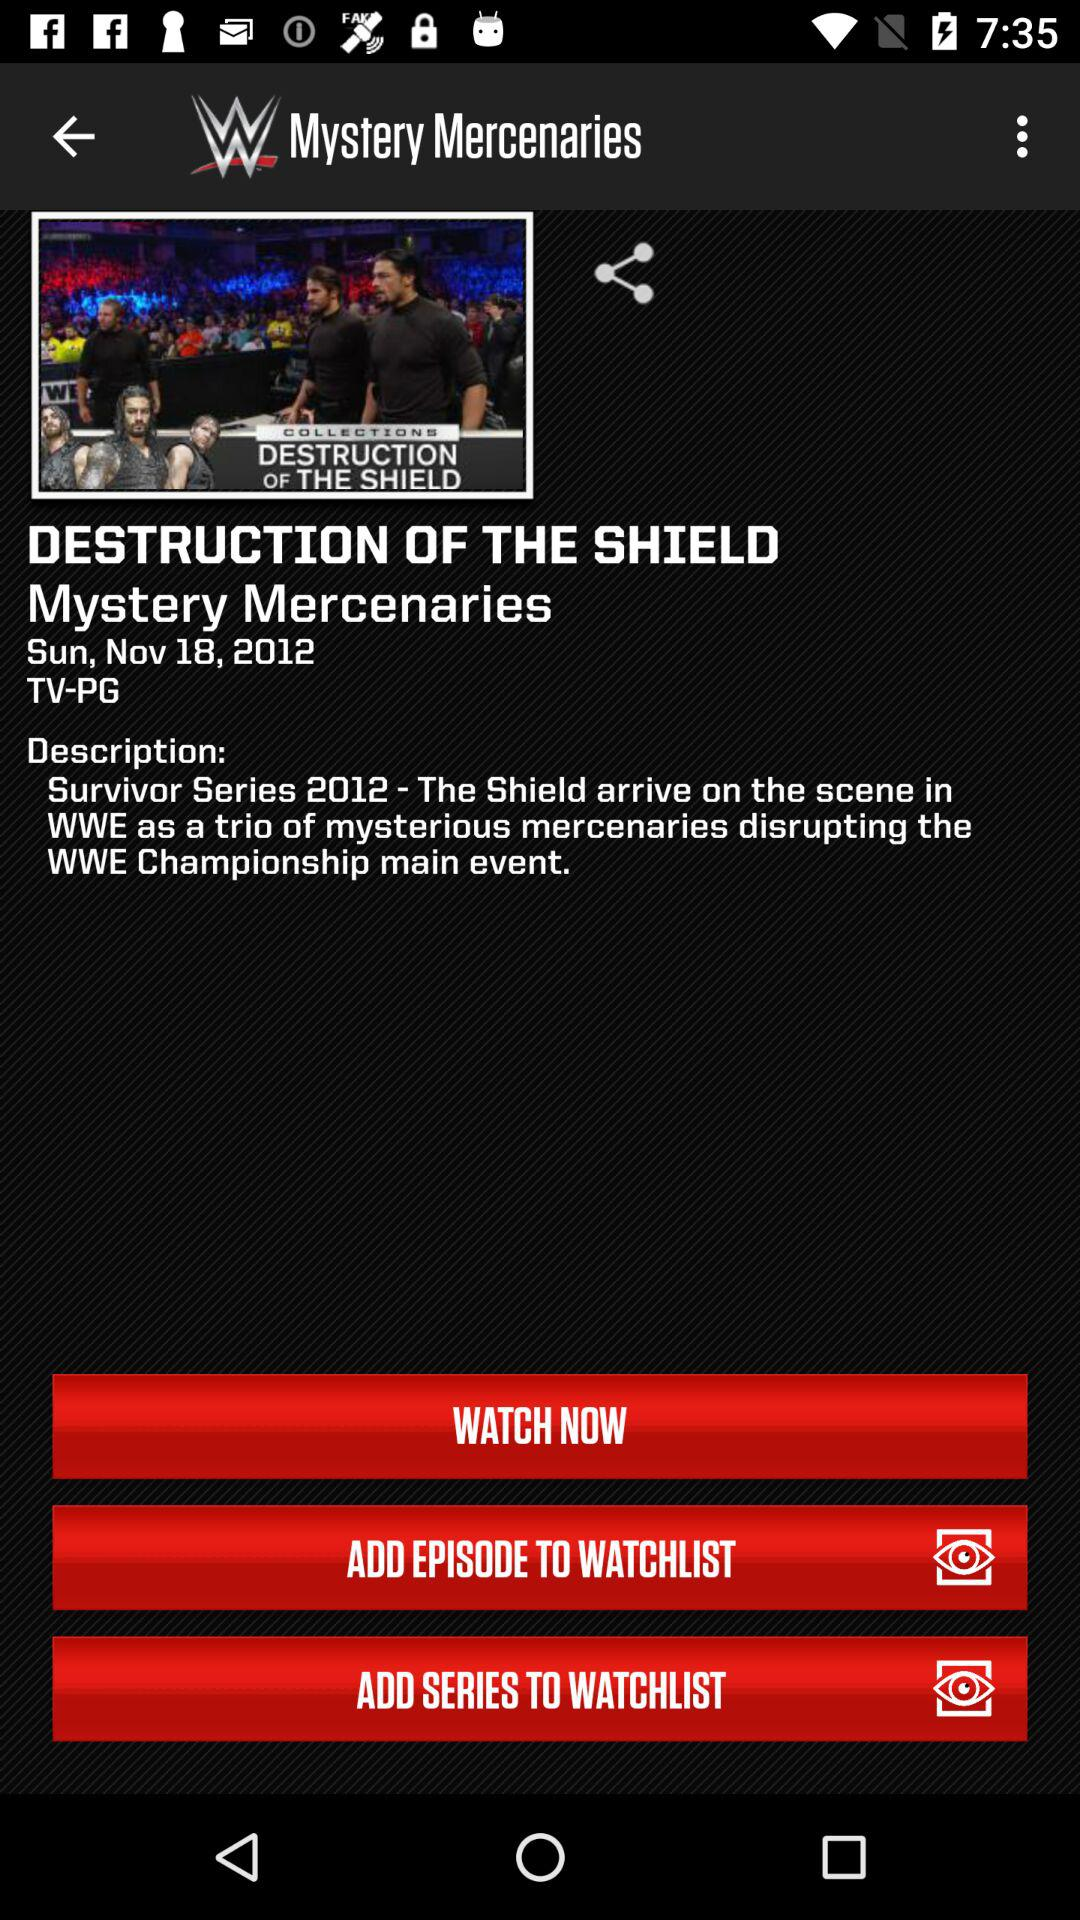What is the date of the episode? The date of the episode is Sunday, November 18, 2012. 